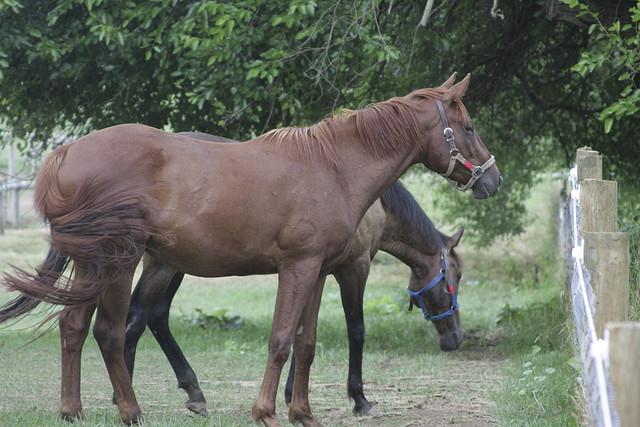How many horses are there?
Give a very brief answer. 2. What color is the bridle on the rear horse?
Short answer required. Blue. How many white feet does this horse have?
Write a very short answer. 0. Is this an adult horse?
Short answer required. Yes. What color are the horses?
Give a very brief answer. Brown. What color is the horse?
Keep it brief. Brown. 